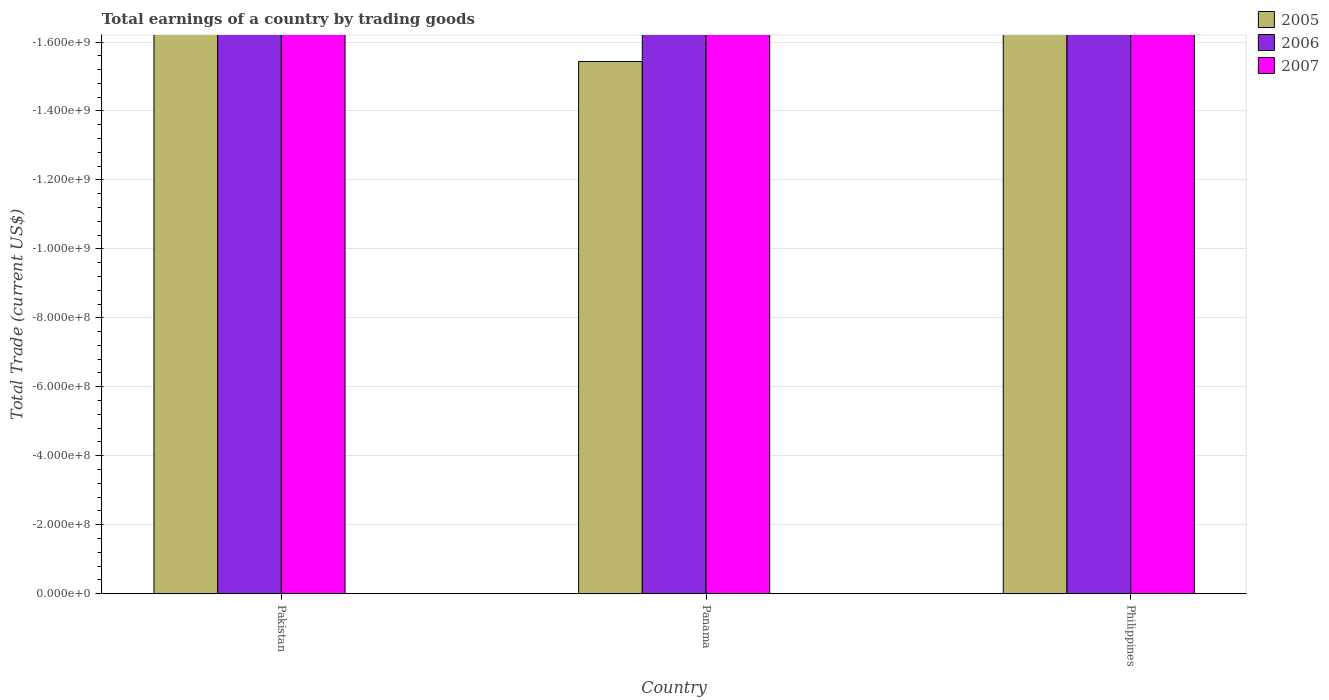How many bars are there on the 3rd tick from the left?
Ensure brevity in your answer.  0. What is the label of the 2nd group of bars from the left?
Keep it short and to the point. Panama. Across all countries, what is the minimum total earnings in 2005?
Provide a short and direct response. 0. What is the difference between the total earnings in 2005 in Panama and the total earnings in 2006 in Pakistan?
Ensure brevity in your answer.  0. What is the average total earnings in 2007 per country?
Give a very brief answer. 0. In how many countries, is the total earnings in 2007 greater than -880000000 US$?
Give a very brief answer. 0. In how many countries, is the total earnings in 2005 greater than the average total earnings in 2005 taken over all countries?
Your answer should be very brief. 0. Is it the case that in every country, the sum of the total earnings in 2005 and total earnings in 2007 is greater than the total earnings in 2006?
Ensure brevity in your answer.  No. How many countries are there in the graph?
Your answer should be very brief. 3. Are the values on the major ticks of Y-axis written in scientific E-notation?
Your answer should be compact. Yes. Does the graph contain any zero values?
Your response must be concise. Yes. Does the graph contain grids?
Provide a succinct answer. Yes. Where does the legend appear in the graph?
Your answer should be compact. Top right. How many legend labels are there?
Make the answer very short. 3. What is the title of the graph?
Provide a short and direct response. Total earnings of a country by trading goods. What is the label or title of the X-axis?
Provide a succinct answer. Country. What is the label or title of the Y-axis?
Provide a short and direct response. Total Trade (current US$). What is the Total Trade (current US$) of 2006 in Pakistan?
Give a very brief answer. 0. What is the Total Trade (current US$) in 2007 in Pakistan?
Offer a terse response. 0. What is the Total Trade (current US$) of 2006 in Panama?
Your answer should be compact. 0. What is the total Total Trade (current US$) of 2006 in the graph?
Your answer should be very brief. 0. What is the total Total Trade (current US$) in 2007 in the graph?
Keep it short and to the point. 0. What is the average Total Trade (current US$) in 2006 per country?
Your response must be concise. 0. 